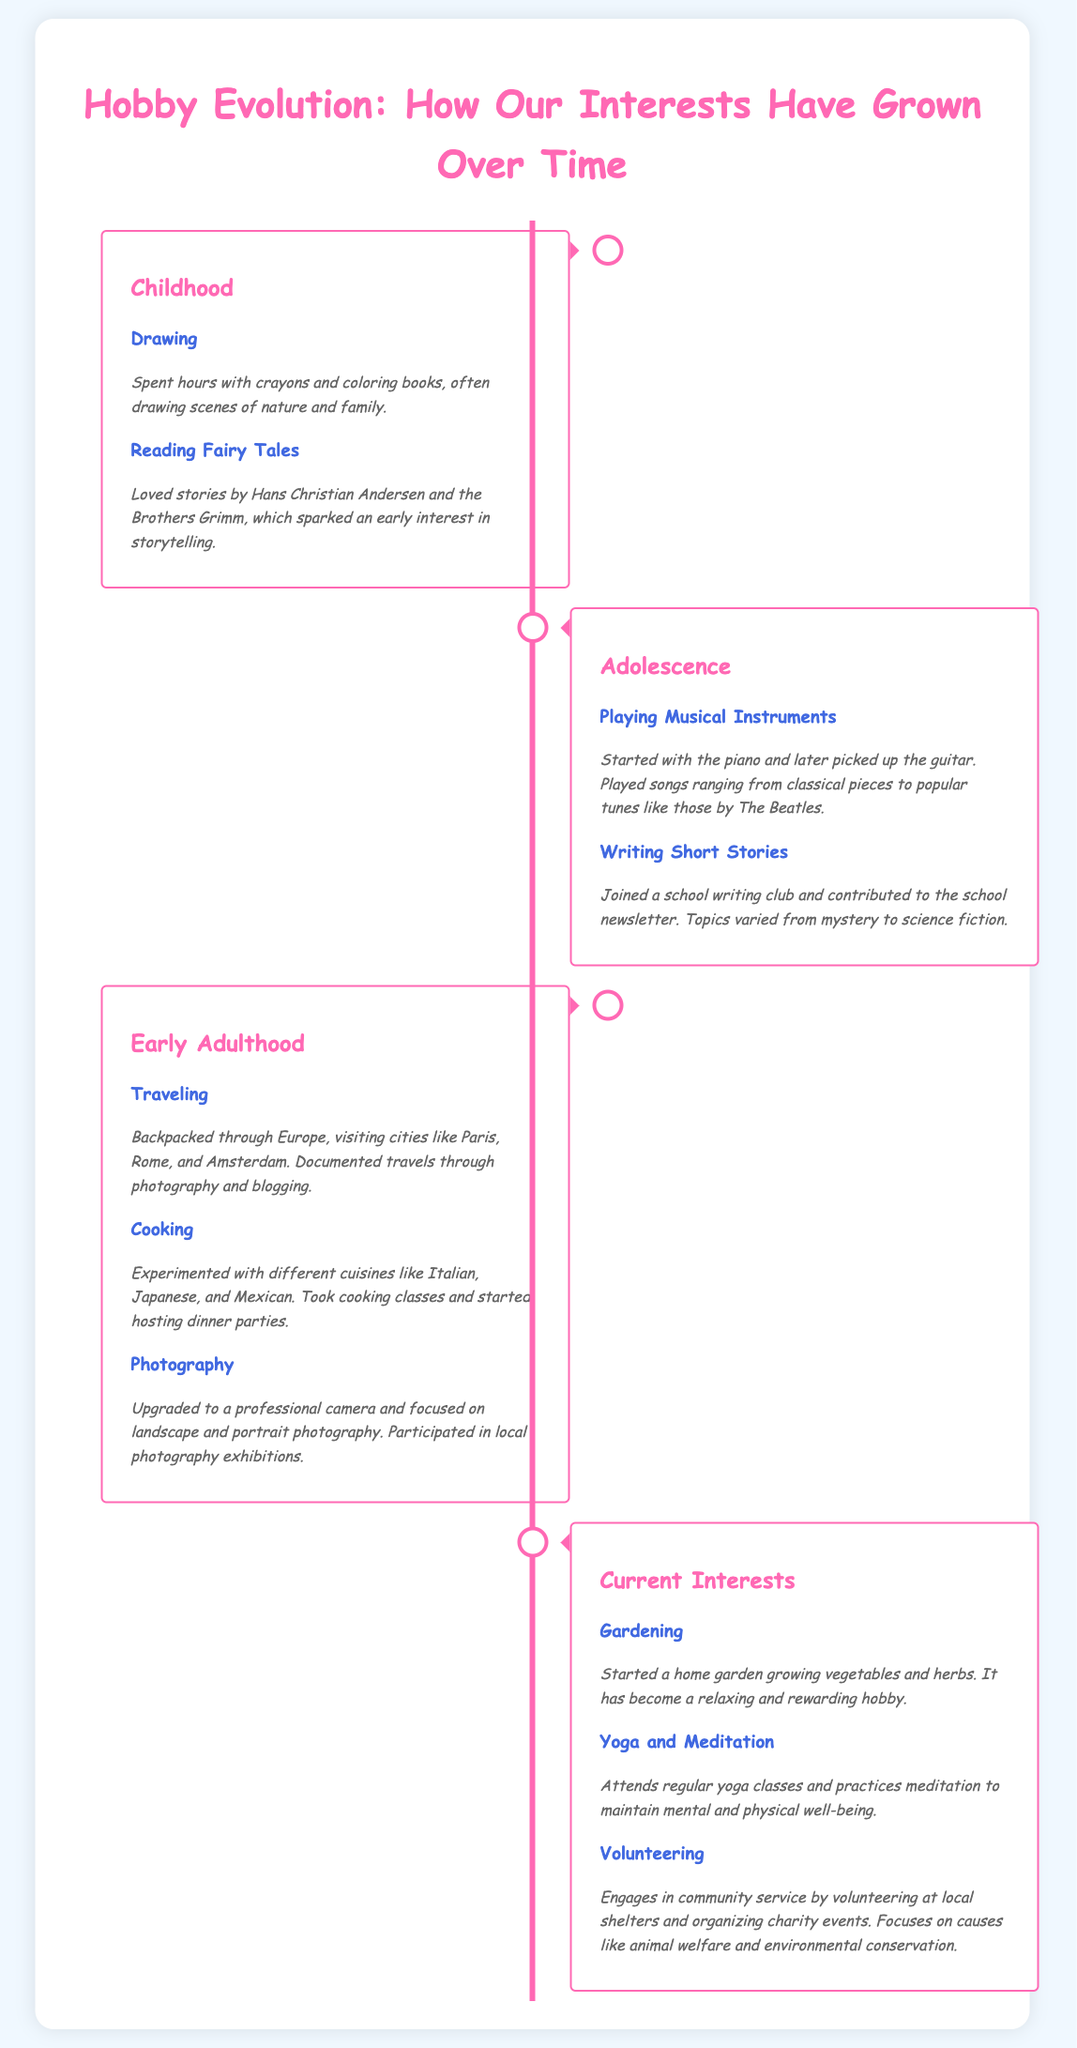What hobbies were explored in childhood? The document mentions drawing and reading fairy tales as hobbies from childhood.
Answer: drawing, reading fairy tales Which musical instrument was first learned? The document states that playing musical instruments began with the piano.
Answer: piano What cooking activities took place during early adulthood? The document describes experimenting with different cuisines and taking cooking classes as cooking activities.
Answer: experimenting with different cuisines, taking cooking classes What is a current interest focused on physical well-being? The document lists yoga and meditation as hobbies that maintain mental and physical well-being.
Answer: yoga and meditation How many specific hobbies are mentioned in current interests? The document outlines three current interests: gardening, yoga and meditation, and volunteering.
Answer: three What was a method of documenting travels in early adulthood? The document specifies that travels were documented through photography and blogging.
Answer: photography and blogging In which age category does traveling fall? The document indicates that traveling is part of early adulthood interests.
Answer: early adulthood Which interest involves community service? The document highlights volunteering as an interest focused on community service.
Answer: volunteering 